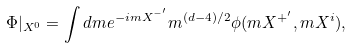<formula> <loc_0><loc_0><loc_500><loc_500>\Phi | _ { X ^ { 0 } } = \int d m e ^ { - i m X ^ { - ^ { \prime } } } m ^ { ( d - 4 ) / 2 } \phi ( m X ^ { + ^ { \prime } } , m X ^ { i } ) ,</formula> 